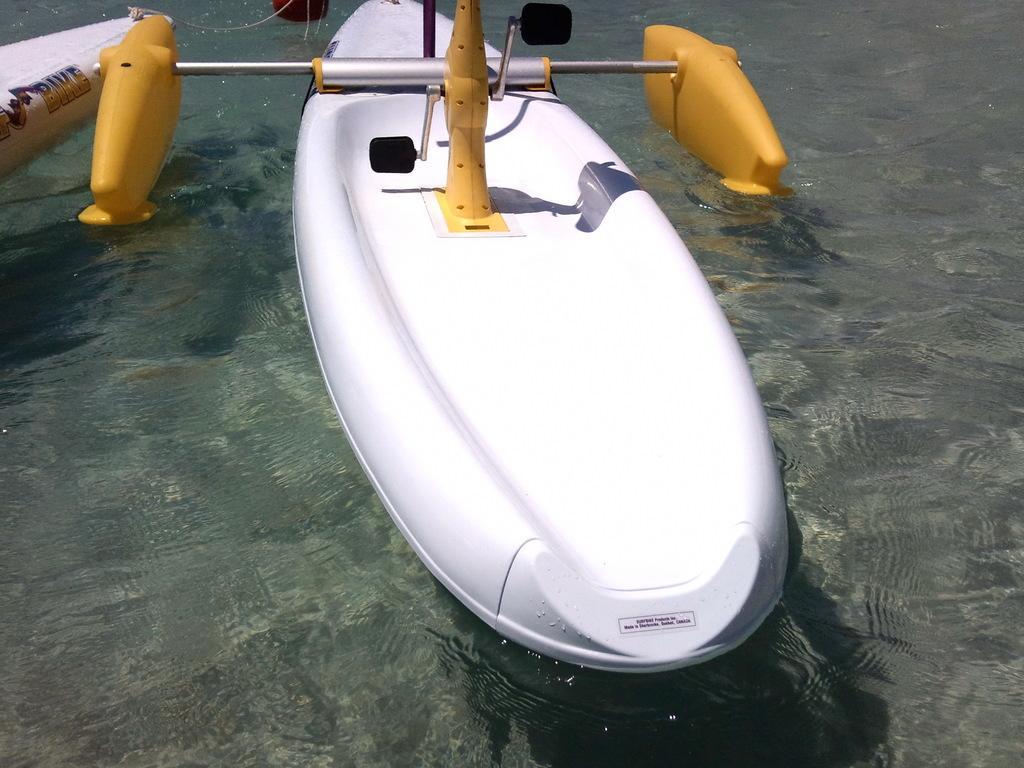How would you summarize this image in a sentence or two? Here we can see boats are above the water. Top of the image, we can see rods and pedal. 